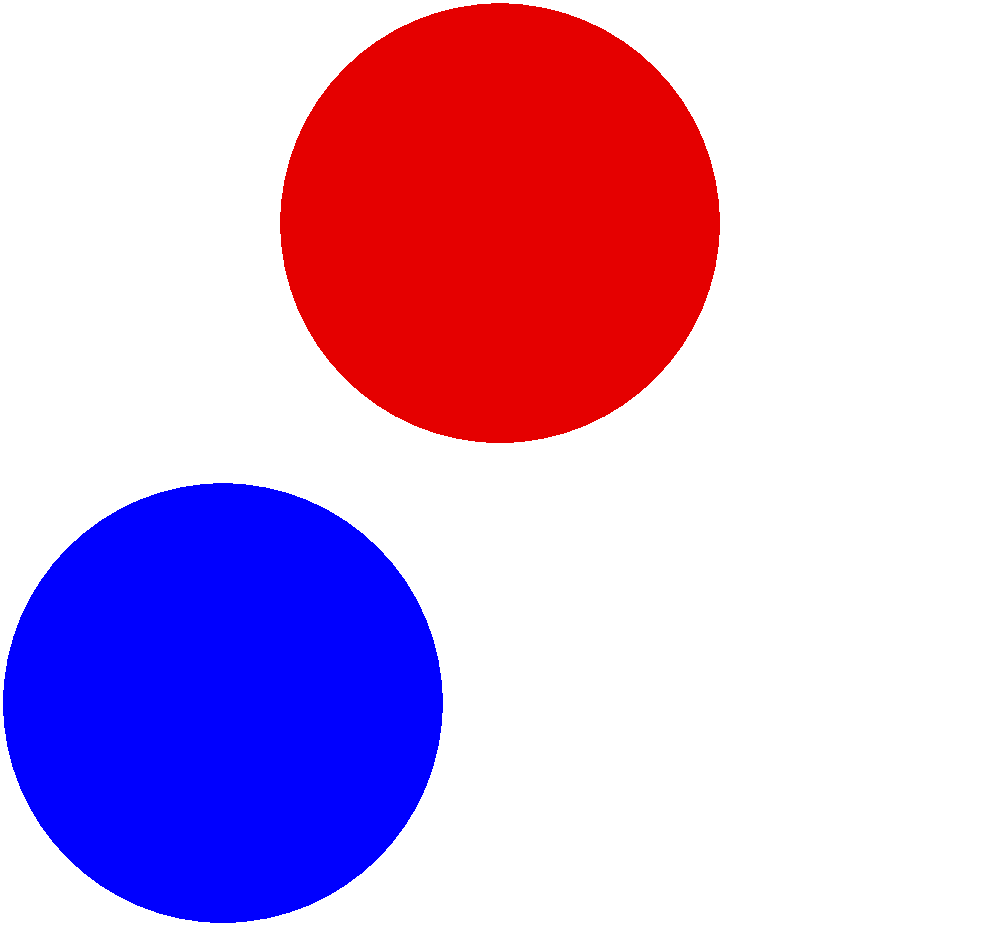Which German car brand is represented by this logo design? To identify the German car brand represented by this logo, let's analyze its key features:

1. The logo consists of three overlapping circles arranged in a triangular formation.
2. The colors used are blue, white, and red (with a slight orange tint).
3. The arrangement of the circles creates a propeller-like shape.

These characteristics are distinctive of the BMW (Bayerische Motoren Werke) logo:

1. The three circles represent the company's origins in aircraft engine manufacturing.
2. The blue and white colors are derived from the Bavarian flag, reflecting the company's home state.
3. The red circle was added later to complete the propeller image and add visual appeal.

BMW has a long history in German automotive engineering, dating back to 1916. The logo design has remained largely consistent throughout the years, making it one of the most recognizable car logos worldwide.

For a middle-aged German woman, this logo would likely be familiar from seeing BMW cars on German roads throughout her life, even if she wasn't particularly interested in techno music or club culture in her youth.
Answer: BMW (Bayerische Motoren Werke) 